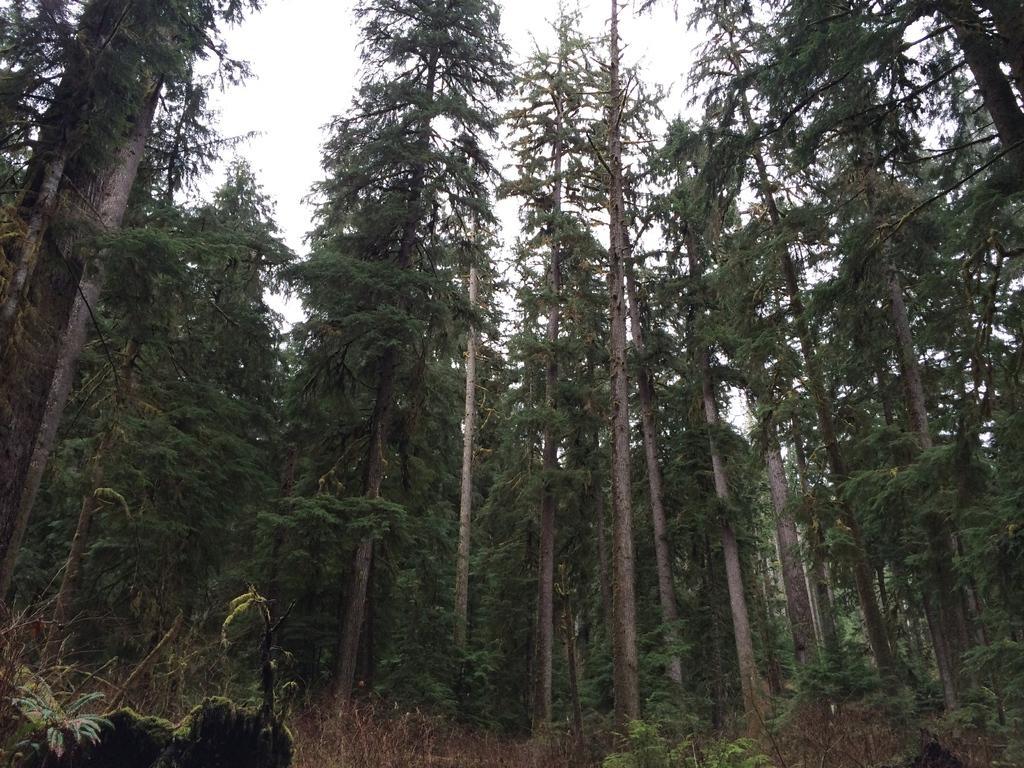Can you describe this image briefly? In this picture I can see few trees and few plants on the ground and I can see a cloudy sky. 